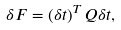<formula> <loc_0><loc_0><loc_500><loc_500>\delta F = \left ( \delta t \right ) ^ { T } Q \delta t ,</formula> 